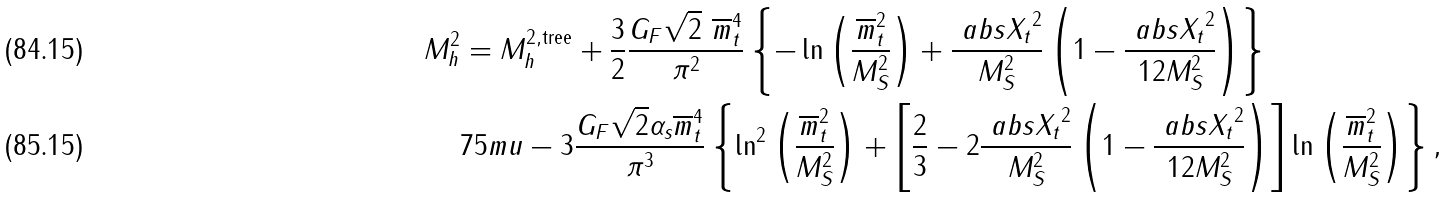Convert formula to latex. <formula><loc_0><loc_0><loc_500><loc_500>M _ { h } ^ { 2 } & = M _ { h } ^ { 2 , \text {tree} } + \frac { 3 } { 2 } \frac { G _ { F } \sqrt { 2 } \ \overline { m } _ { t } ^ { 4 } } { \pi ^ { 2 } } \left \{ - \ln \left ( \frac { \overline { m } ^ { 2 } _ { t } } { M _ { S } ^ { 2 } } \right ) + \frac { \ a b s { X _ { t } } ^ { 2 } } { M _ { S } ^ { 2 } } \left ( 1 - \frac { \ a b s { X _ { t } } ^ { 2 } } { 1 2 M _ { S } ^ { 2 } } \right ) \right \} \\ & { 7 5 m u } - 3 \frac { G _ { F } \sqrt { 2 } \alpha _ { s } \overline { m } _ { t } ^ { 4 } } { \pi ^ { 3 } } \left \{ \ln ^ { 2 } \left ( \frac { \overline { m } ^ { 2 } _ { t } } { M _ { S } ^ { 2 } } \right ) + \left [ \frac { 2 } { 3 } - 2 \frac { \ a b s { X _ { t } } ^ { 2 } } { M _ { S } ^ { 2 } } \left ( 1 - \frac { \ a b s { X _ { t } } ^ { 2 } } { 1 2 M _ { S } ^ { 2 } } \right ) \right ] \ln \left ( \frac { \overline { m } ^ { 2 } _ { t } } { M _ { S } ^ { 2 } } \right ) \right \} ,</formula> 